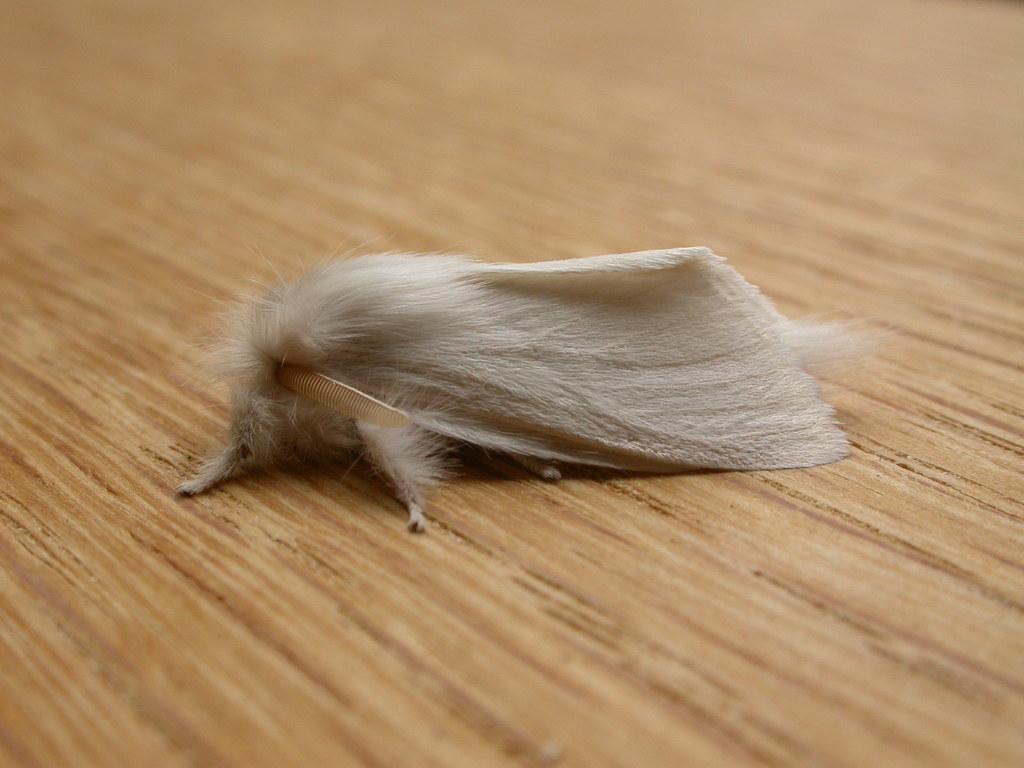Could you give a brief overview of what you see in this image? In this image in the center there is one animal, at the bottom there is a wooden floor. 